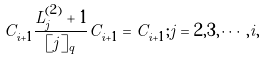Convert formula to latex. <formula><loc_0><loc_0><loc_500><loc_500>C _ { i + 1 } \frac { L _ { j } ^ { ( 2 ) } + 1 } { [ j ] _ { q } } C _ { i + 1 } = C _ { i + 1 } ; j = 2 , 3 , \cdots , i ,</formula> 